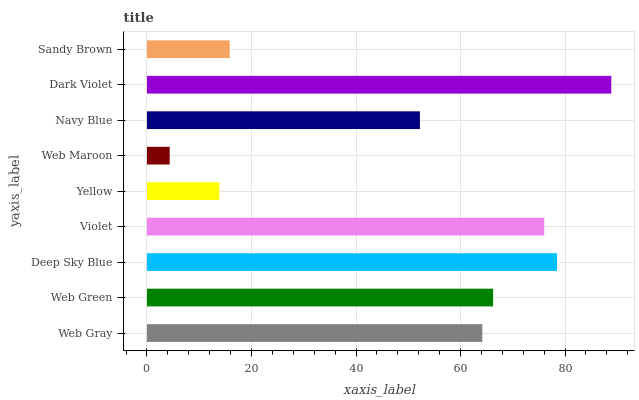Is Web Maroon the minimum?
Answer yes or no. Yes. Is Dark Violet the maximum?
Answer yes or no. Yes. Is Web Green the minimum?
Answer yes or no. No. Is Web Green the maximum?
Answer yes or no. No. Is Web Green greater than Web Gray?
Answer yes or no. Yes. Is Web Gray less than Web Green?
Answer yes or no. Yes. Is Web Gray greater than Web Green?
Answer yes or no. No. Is Web Green less than Web Gray?
Answer yes or no. No. Is Web Gray the high median?
Answer yes or no. Yes. Is Web Gray the low median?
Answer yes or no. Yes. Is Web Green the high median?
Answer yes or no. No. Is Web Green the low median?
Answer yes or no. No. 